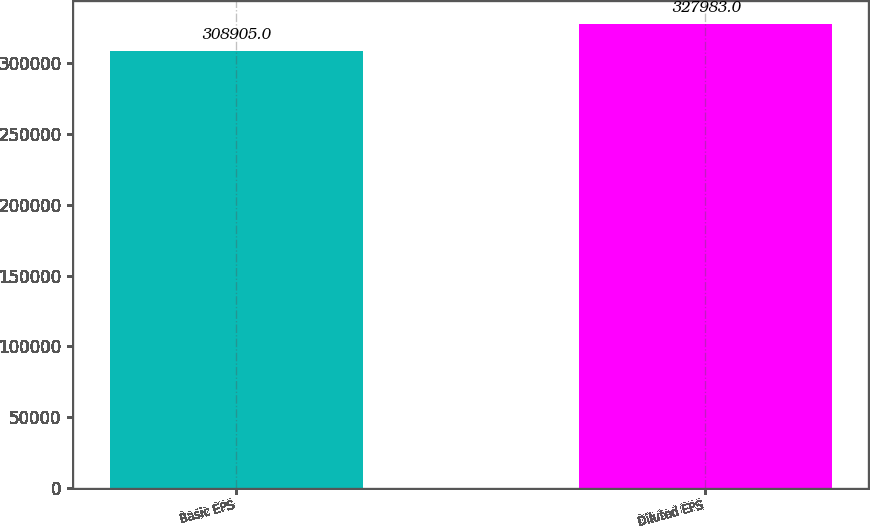Convert chart. <chart><loc_0><loc_0><loc_500><loc_500><bar_chart><fcel>Basic EPS<fcel>Diluted EPS<nl><fcel>308905<fcel>327983<nl></chart> 